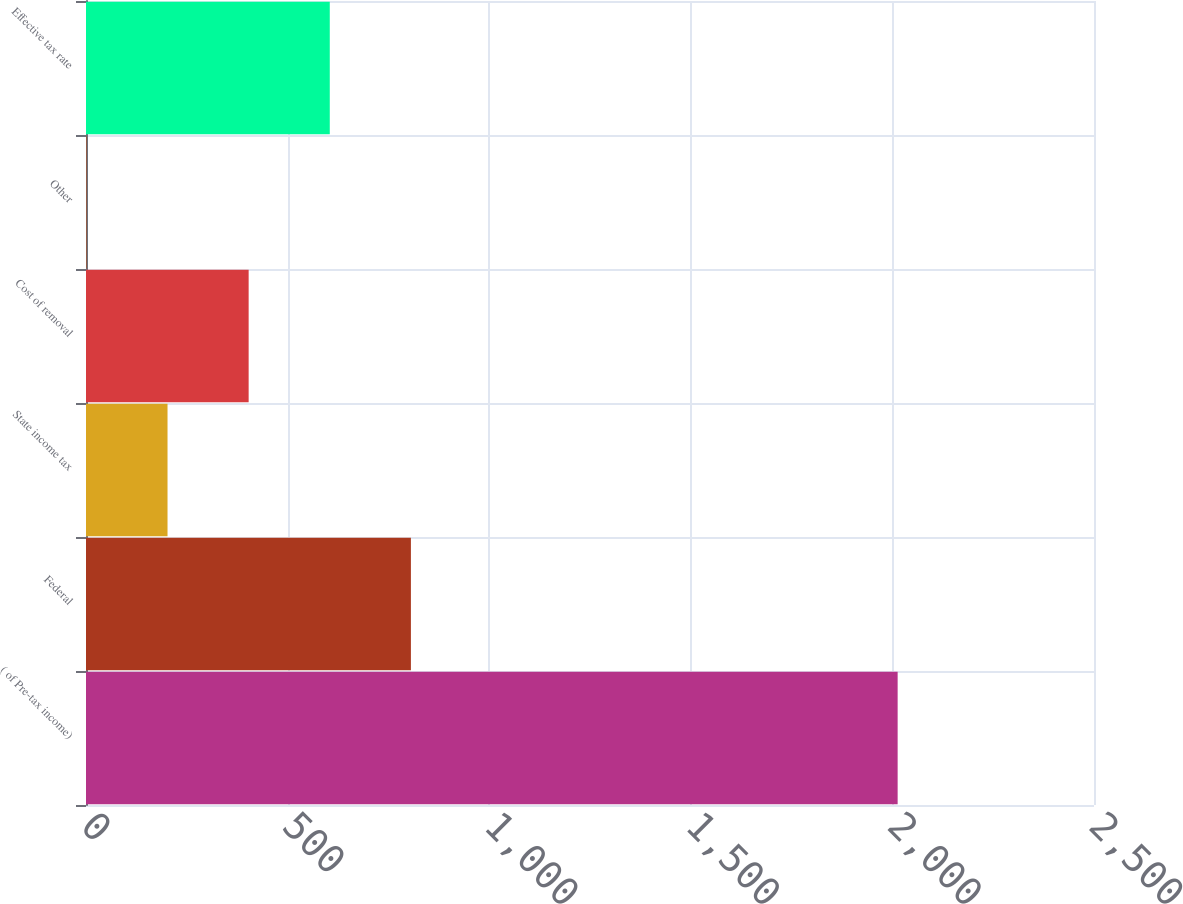Convert chart. <chart><loc_0><loc_0><loc_500><loc_500><bar_chart><fcel>( of Pre-tax income)<fcel>Federal<fcel>State income tax<fcel>Cost of removal<fcel>Other<fcel>Effective tax rate<nl><fcel>2013<fcel>805.8<fcel>202.2<fcel>403.4<fcel>1<fcel>604.6<nl></chart> 